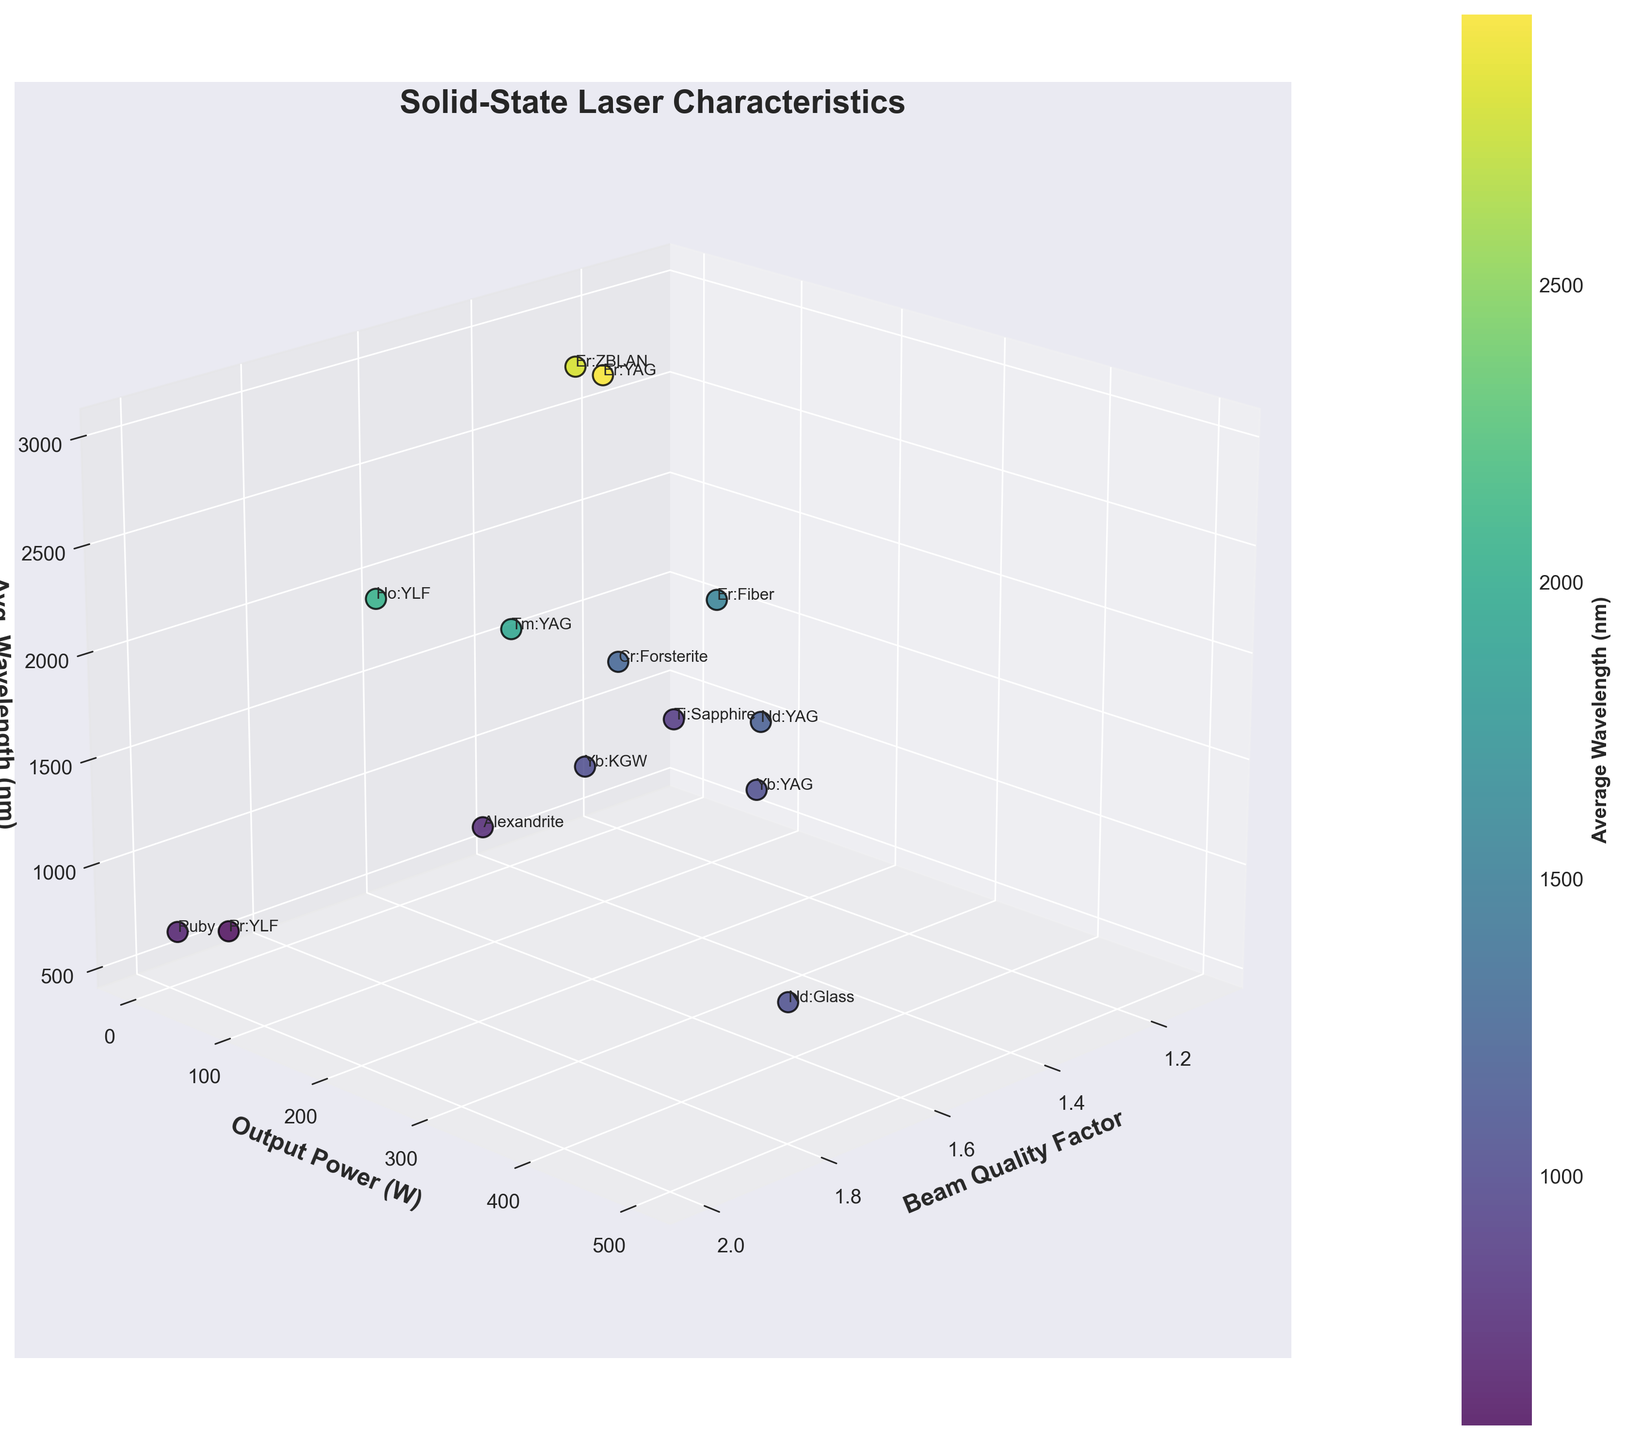How many distinct data points are represented in the 3D scatter plot? The plot includes one point for each type of laser listed in the data. By counting the unique laser types, we get the total number of data points.
Answer: 14 What is the title of the 3D scatter plot? The title is clearly displayed at the top of the plot.
Answer: Solid-State Laser Characteristics Which laser type has the highest output power? By looking at the y-axis labeled "Output Power (W)" and identifying the data point with the highest value on this axis, we find the corresponding laser type.
Answer: Nd:Glass What is the beam quality factor for the laser with the lowest output power? Identify the point with the lowest value on the y-axis ("Output Power (W)") and then find the corresponding beam quality factor on the x-axis.
Answer: 1.9 (Pr:YLF) Which laser types fall within the average wavelength range of 650-1100 nm? Look at the z-axis, labeled as average wavelength, and identify the points that fall between 650 and 1100 nm. The corresponding laser types are in this range.
Answer: Ti:Sapphire, Ruby, Alexandrite What is the average output power of lasers with a beam quality factor less than 1.5? First, identify lasers with a beam quality factor below 1.5. Then sum their output power values and divide by the number of such lasers. Lasers meeting the criterion: Nd:YAG (150 W), Ti:Sapphire (5 W), Er:Fiber (50 W), Cr:Forsterite (2 W); Average output power = (150 + 5 + 50 + 2) / 4
Answer: 51.75 Between the Ti:Sapphire and Yb:YAG lasers, which one has a wider wavelength tuning range? Calculate the wavelength tuning range for both lasers by subtracting the starting wavelength from the ending wavelength. Compare the results. Ti:Sapphire range: 1100 - 650 = 450 nm, Yb:YAG range: 1050 - 1020 = 30 nm.
Answer: Ti:Sapphire Which lasers have an average wavelength above 2500 nm? Look at the z-axis and identify points that lie above 2500 nm and note the corresponding laser types.
Answer: Er:YAG, Er:ZBLAN Which laser has the lowest beam quality factor, and what is its output power? Identify the data point with the smallest value on the x-axis ("Beam Quality Factor") and note the corresponding output power from the y-axis.
Answer: Ti:Sapphire, 5 W How does the beam quality factor of Nd:YAG compare to that of Ruby? Identify the beam quality factors of both Nd:YAG and Ruby on the x-axis and compare them. Nd:YAG: 1.2, Ruby: 2.0.
Answer: Nd:YAG has a lower beam quality factor than Ruby 